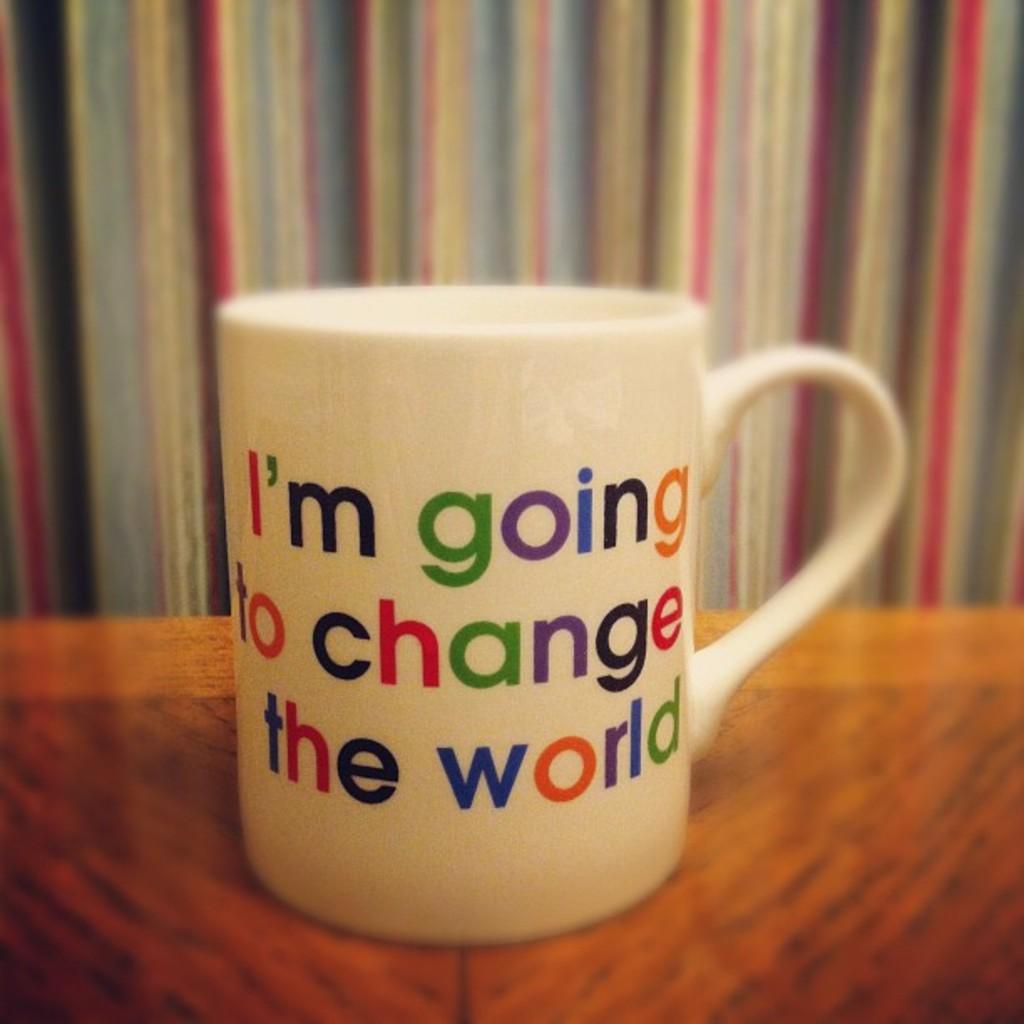Who is going to change the world?
Give a very brief answer. I'm. Change the what?
Ensure brevity in your answer.  World. 